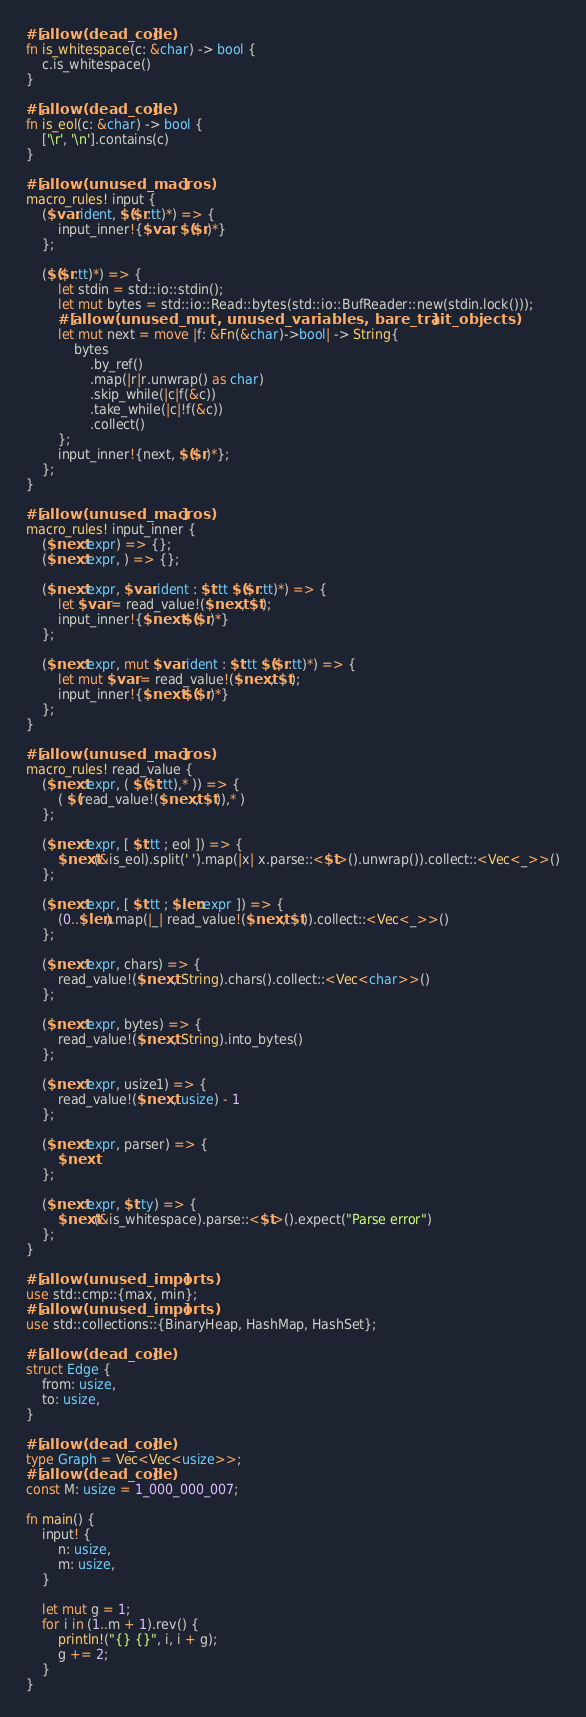<code> <loc_0><loc_0><loc_500><loc_500><_Rust_>#[allow(dead_code)]
fn is_whitespace(c: &char) -> bool {
    c.is_whitespace()
}

#[allow(dead_code)]
fn is_eol(c: &char) -> bool {
    ['\r', '\n'].contains(c)
}

#[allow(unused_macros)]
macro_rules! input {
    ($var:ident, $($r:tt)*) => {
        input_inner!{$var, $($r)*}
    };

    ($($r:tt)*) => {
        let stdin = std::io::stdin();
        let mut bytes = std::io::Read::bytes(std::io::BufReader::new(stdin.lock()));
        #[allow(unused_mut, unused_variables, bare_trait_objects)]
        let mut next = move |f: &Fn(&char)->bool| -> String{
            bytes
                .by_ref()
                .map(|r|r.unwrap() as char)
                .skip_while(|c|f(&c))
                .take_while(|c|!f(&c))
                .collect()
        };
        input_inner!{next, $($r)*};
    };
}

#[allow(unused_macros)]
macro_rules! input_inner {
    ($next:expr) => {};
    ($next:expr, ) => {};

    ($next:expr, $var:ident : $t:tt $($r:tt)*) => {
        let $var = read_value!($next, $t);
        input_inner!{$next $($r)*}
    };

    ($next:expr, mut $var:ident : $t:tt $($r:tt)*) => {
        let mut $var = read_value!($next, $t);
        input_inner!{$next $($r)*}
    };
}

#[allow(unused_macros)]
macro_rules! read_value {
    ($next:expr, ( $($t:tt),* )) => {
        ( $(read_value!($next, $t)),* )
    };

    ($next:expr, [ $t:tt ; eol ]) => {
        $next(&is_eol).split(' ').map(|x| x.parse::<$t>().unwrap()).collect::<Vec<_>>()
    };

    ($next:expr, [ $t:tt ; $len:expr ]) => {
        (0..$len).map(|_| read_value!($next, $t)).collect::<Vec<_>>()
    };

    ($next:expr, chars) => {
        read_value!($next, String).chars().collect::<Vec<char>>()
    };

    ($next:expr, bytes) => {
        read_value!($next, String).into_bytes()
    };

    ($next:expr, usize1) => {
        read_value!($next, usize) - 1
    };

    ($next:expr, parser) => {
        $next
    };

    ($next:expr, $t:ty) => {
        $next(&is_whitespace).parse::<$t>().expect("Parse error")
    };
}

#[allow(unused_imports)]
use std::cmp::{max, min};
#[allow(unused_imports)]
use std::collections::{BinaryHeap, HashMap, HashSet};

#[allow(dead_code)]
struct Edge {
    from: usize,
    to: usize,
}

#[allow(dead_code)]
type Graph = Vec<Vec<usize>>;
#[allow(dead_code)]
const M: usize = 1_000_000_007;

fn main() {
    input! {
        n: usize,
        m: usize,
    }

    let mut g = 1;
    for i in (1..m + 1).rev() {
        println!("{} {}", i, i + g);
        g += 2;
    }
}
</code> 